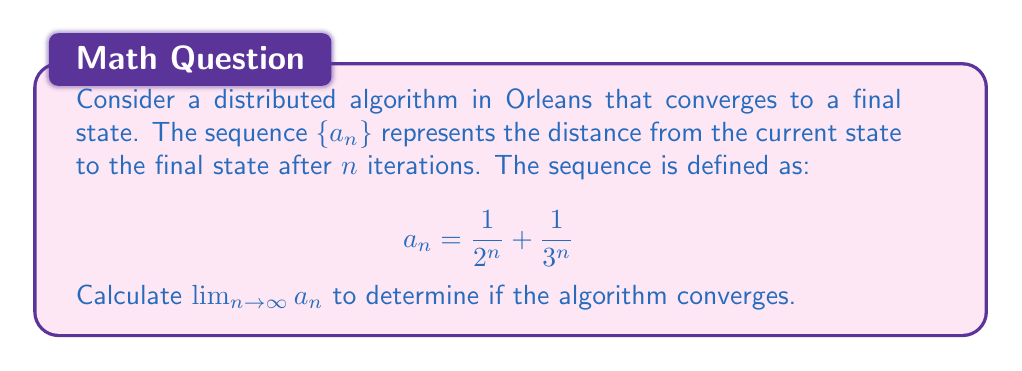Can you solve this math problem? To solve this problem, let's break it down into steps:

1) First, we need to understand what the limit means in this context. The limit of this sequence as $n$ approaches infinity will tell us if the algorithm converges (limit exists and equals 0) or not.

2) We can calculate the limit of each term separately and then add them:

   $\lim_{n \to \infty} a_n = \lim_{n \to \infty} (\frac{1}{2^n} + \frac{1}{3^n})$
   $= \lim_{n \to \infty} \frac{1}{2^n} + \lim_{n \to \infty} \frac{1}{3^n}$

3) Let's look at $\lim_{n \to \infty} \frac{1}{2^n}$:
   As $n$ gets very large, $2^n$ becomes an extremely large number, so $\frac{1}{2^n}$ approaches 0.
   
   $\lim_{n \to \infty} \frac{1}{2^n} = 0$

4) Similarly for $\lim_{n \to \infty} \frac{1}{3^n}$:
   As $n$ gets very large, $3^n$ becomes an even larger number than $2^n$, so $\frac{1}{3^n}$ also approaches 0.
   
   $\lim_{n \to \infty} \frac{1}{3^n} = 0$

5) Now we can add these limits:

   $\lim_{n \to \infty} a_n = \lim_{n \to \infty} \frac{1}{2^n} + \lim_{n \to \infty} \frac{1}{3^n} = 0 + 0 = 0$

6) Since the limit exists and equals 0, we can conclude that the sequence converges to 0, which means the distributed algorithm converges to its final state.
Answer: $\lim_{n \to \infty} a_n = 0$ 